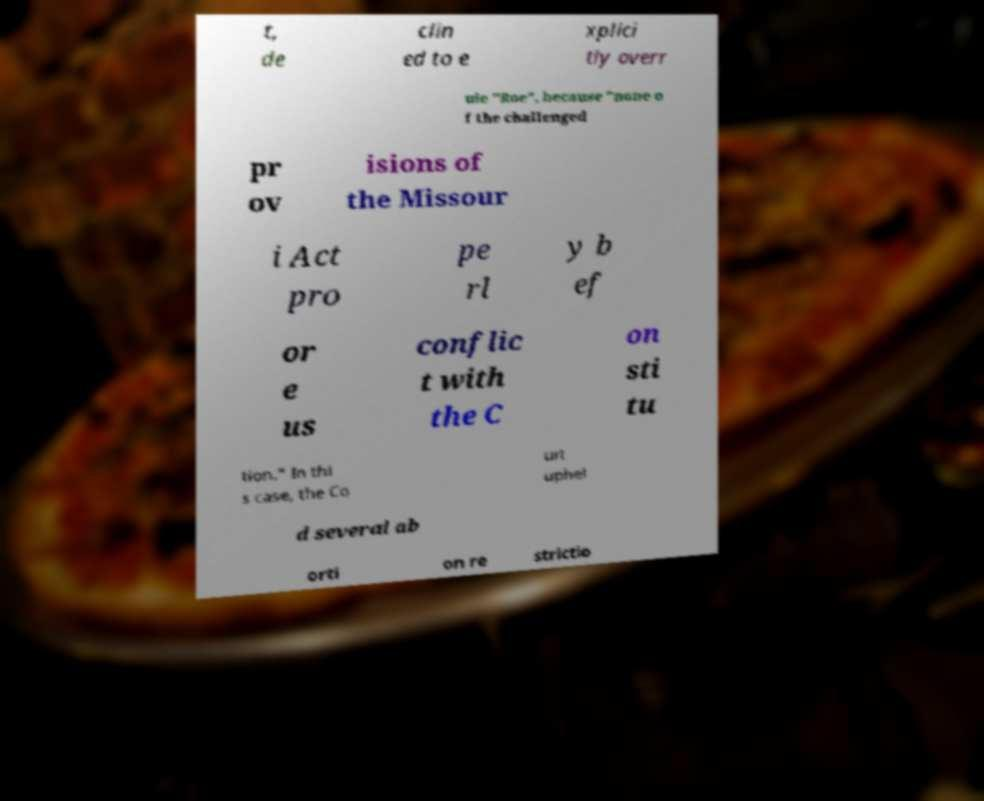Could you extract and type out the text from this image? t, de clin ed to e xplici tly overr ule "Roe", because "none o f the challenged pr ov isions of the Missour i Act pro pe rl y b ef or e us conflic t with the C on sti tu tion." In thi s case, the Co urt uphel d several ab orti on re strictio 